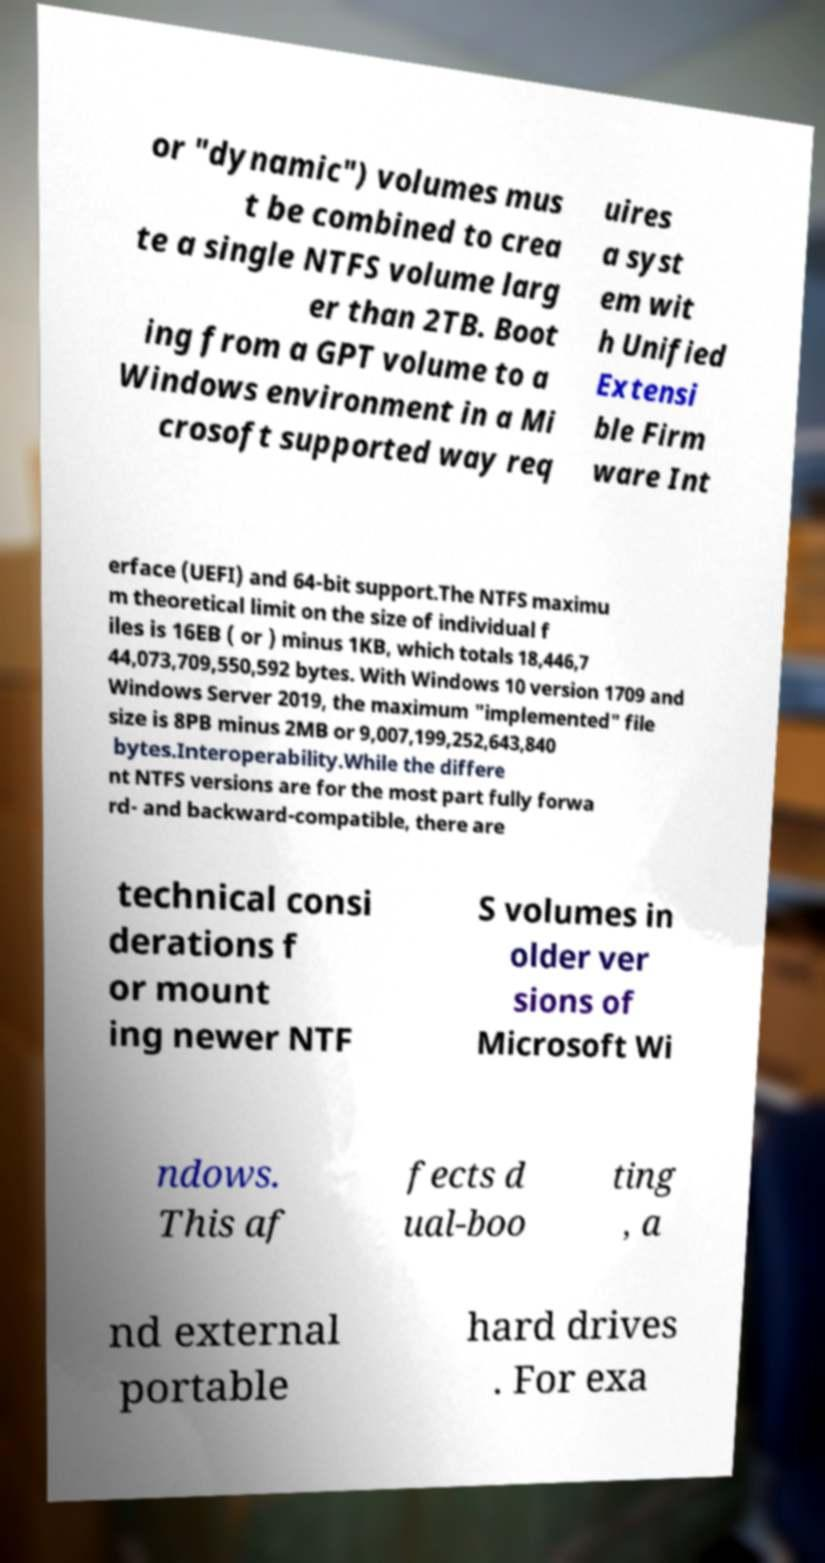I need the written content from this picture converted into text. Can you do that? or "dynamic") volumes mus t be combined to crea te a single NTFS volume larg er than 2TB. Boot ing from a GPT volume to a Windows environment in a Mi crosoft supported way req uires a syst em wit h Unified Extensi ble Firm ware Int erface (UEFI) and 64-bit support.The NTFS maximu m theoretical limit on the size of individual f iles is 16EB ( or ) minus 1KB, which totals 18,446,7 44,073,709,550,592 bytes. With Windows 10 version 1709 and Windows Server 2019, the maximum "implemented" file size is 8PB minus 2MB or 9,007,199,252,643,840 bytes.Interoperability.While the differe nt NTFS versions are for the most part fully forwa rd- and backward-compatible, there are technical consi derations f or mount ing newer NTF S volumes in older ver sions of Microsoft Wi ndows. This af fects d ual-boo ting , a nd external portable hard drives . For exa 